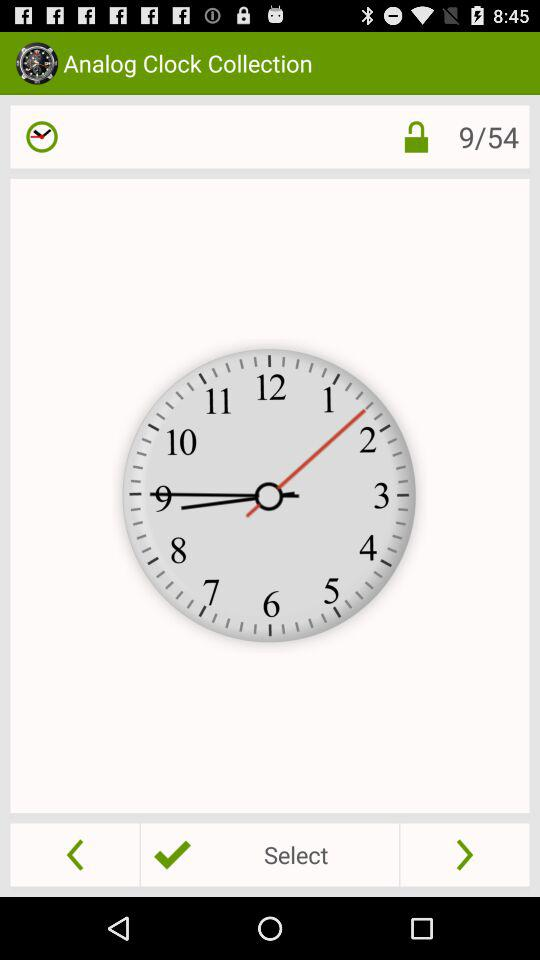What is the total number of images? The total number of images is 54. 